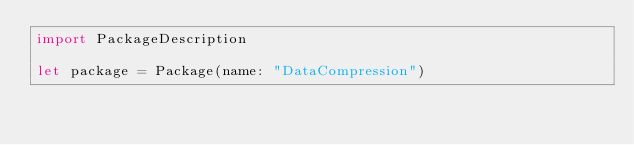<code> <loc_0><loc_0><loc_500><loc_500><_Swift_>import PackageDescription

let package = Package(name: "DataCompression")
</code> 